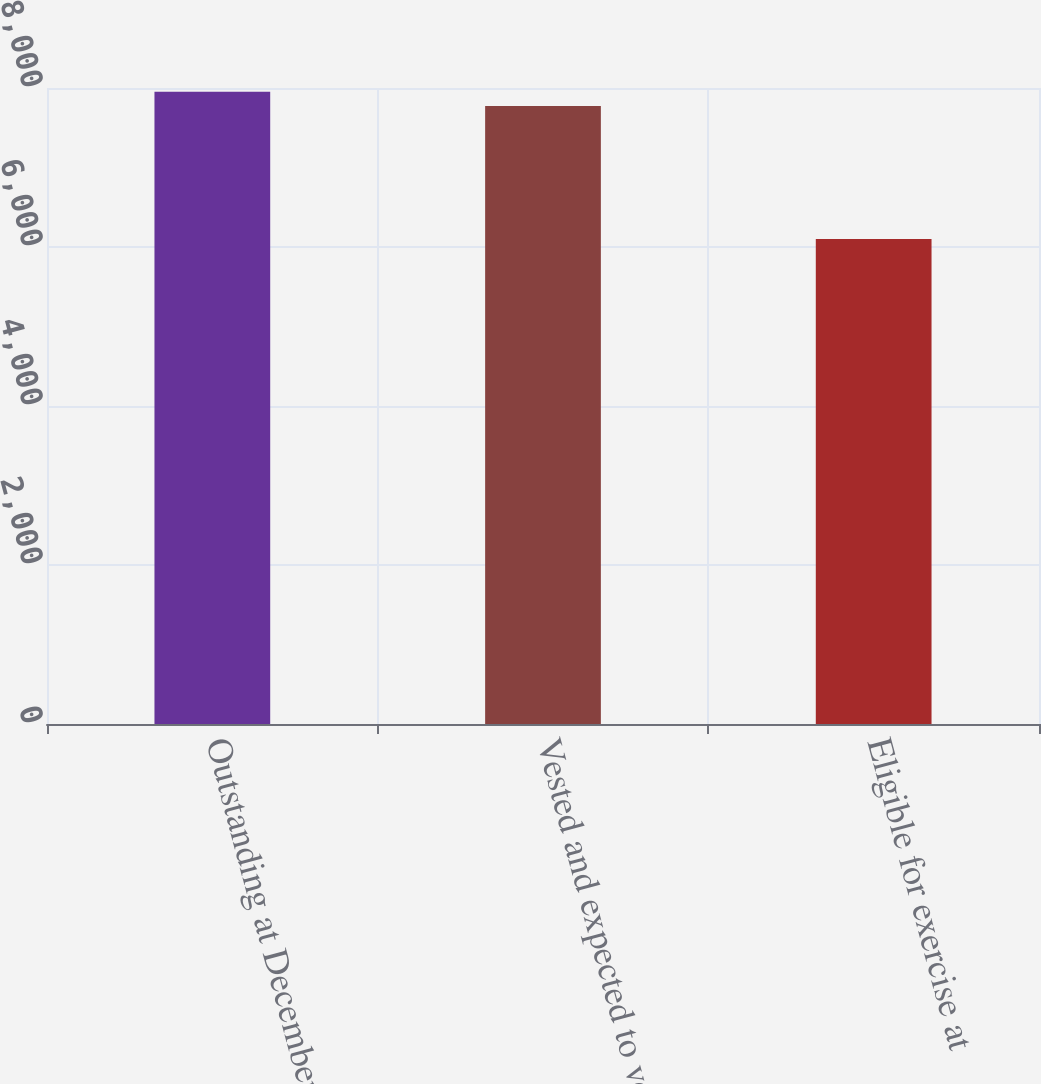Convert chart to OTSL. <chart><loc_0><loc_0><loc_500><loc_500><bar_chart><fcel>Outstanding at December 31<fcel>Vested and expected to vest at<fcel>Eligible for exercise at<nl><fcel>7953.3<fcel>7775<fcel>6100<nl></chart> 